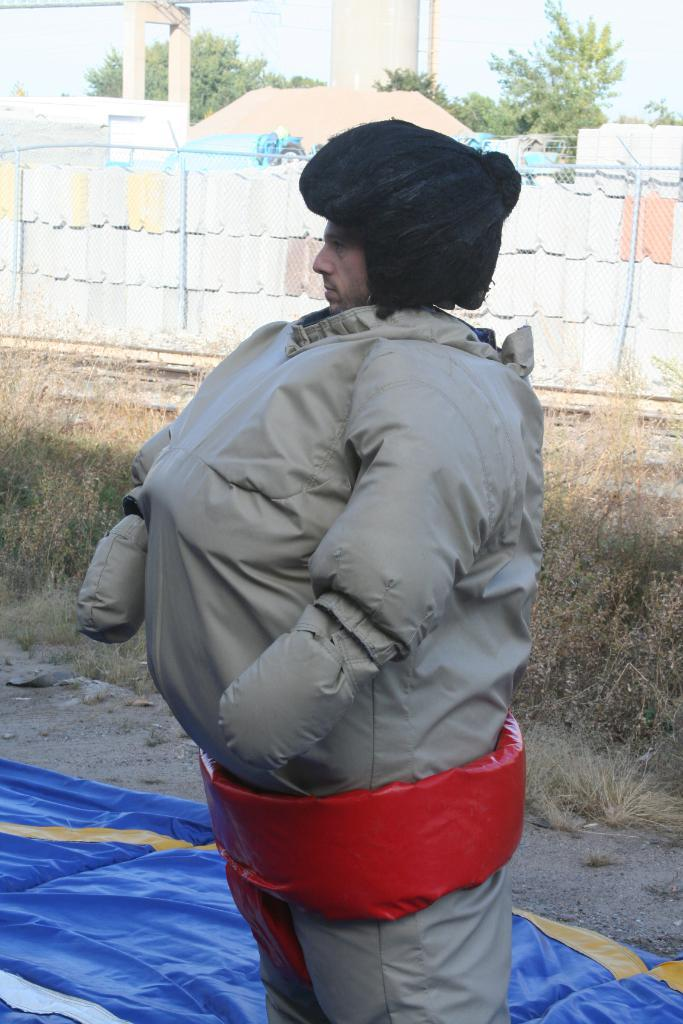What is present in the image? There is a person in the image. What object can be seen in the image? There is a cloth in the image. What can be seen in the background of the image? There is grass, a wall, trees, and the sky visible in the background of the image. What type of toy can be seen being used by the person in the image? There is no toy present in the image; only a person and a cloth are visible. What kind of food is being prepared by the person in the image? There is no food preparation or food visible in the image. 